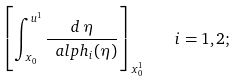Convert formula to latex. <formula><loc_0><loc_0><loc_500><loc_500>\left [ \int _ { x _ { 0 } } ^ { u ^ { 1 } } { \frac { d \, \eta } { \ a l p h _ { i } ( \eta ) } } \right ] _ { x _ { 0 } ^ { 1 } } \quad i = 1 , 2 ;</formula> 